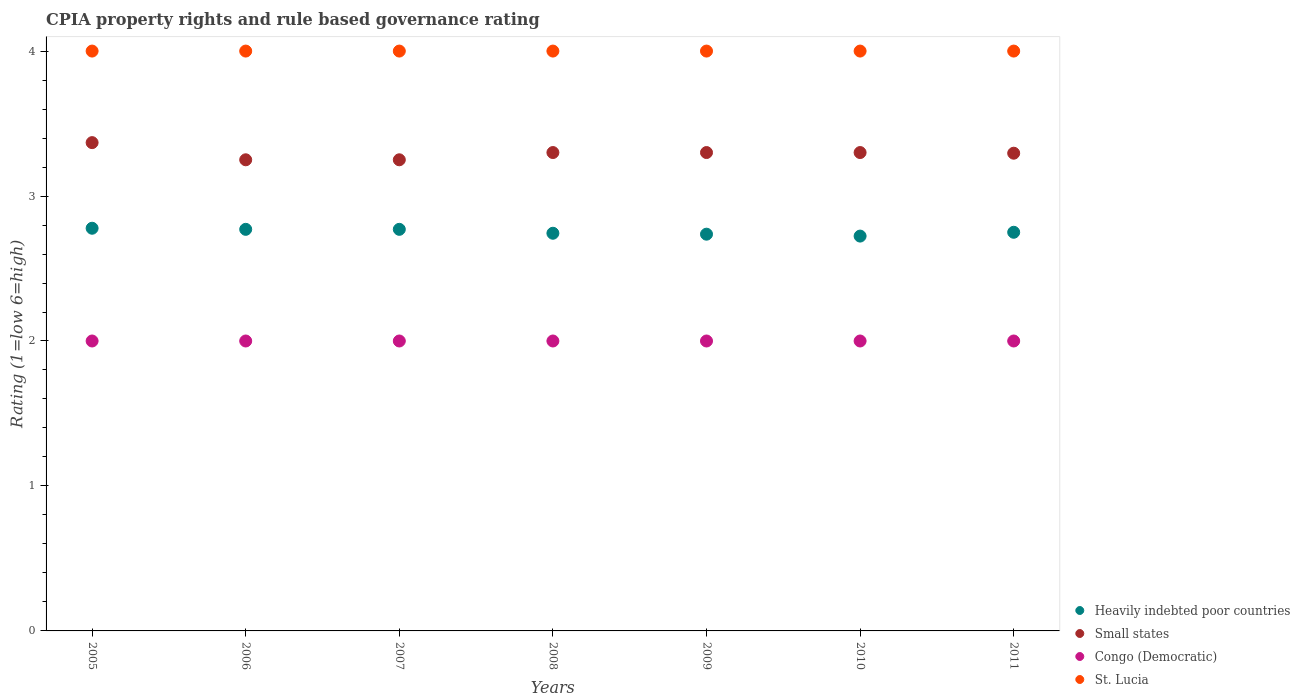How many different coloured dotlines are there?
Offer a terse response. 4. What is the CPIA rating in St. Lucia in 2009?
Your answer should be compact. 4. Across all years, what is the maximum CPIA rating in St. Lucia?
Offer a terse response. 4. Across all years, what is the minimum CPIA rating in Congo (Democratic)?
Make the answer very short. 2. In which year was the CPIA rating in Heavily indebted poor countries maximum?
Keep it short and to the point. 2005. In which year was the CPIA rating in Heavily indebted poor countries minimum?
Provide a short and direct response. 2010. What is the total CPIA rating in Small states in the graph?
Your answer should be compact. 23.06. What is the difference between the CPIA rating in Heavily indebted poor countries in 2008 and that in 2010?
Keep it short and to the point. 0.02. What is the difference between the CPIA rating in St. Lucia in 2011 and the CPIA rating in Congo (Democratic) in 2007?
Make the answer very short. 2. What is the average CPIA rating in Small states per year?
Your answer should be very brief. 3.29. In the year 2005, what is the difference between the CPIA rating in St. Lucia and CPIA rating in Small states?
Offer a very short reply. 0.63. In how many years, is the CPIA rating in St. Lucia greater than 0.6000000000000001?
Offer a terse response. 7. Is the difference between the CPIA rating in St. Lucia in 2005 and 2010 greater than the difference between the CPIA rating in Small states in 2005 and 2010?
Keep it short and to the point. No. What is the difference between the highest and the second highest CPIA rating in Heavily indebted poor countries?
Offer a terse response. 0.01. What is the difference between the highest and the lowest CPIA rating in Small states?
Make the answer very short. 0.12. In how many years, is the CPIA rating in Small states greater than the average CPIA rating in Small states taken over all years?
Your answer should be compact. 5. Is it the case that in every year, the sum of the CPIA rating in Heavily indebted poor countries and CPIA rating in Congo (Democratic)  is greater than the sum of CPIA rating in Small states and CPIA rating in St. Lucia?
Make the answer very short. No. Does the CPIA rating in St. Lucia monotonically increase over the years?
Make the answer very short. No. Is the CPIA rating in Congo (Democratic) strictly less than the CPIA rating in Small states over the years?
Provide a short and direct response. Yes. How many dotlines are there?
Your answer should be very brief. 4. Does the graph contain grids?
Make the answer very short. No. Where does the legend appear in the graph?
Your answer should be very brief. Bottom right. What is the title of the graph?
Provide a succinct answer. CPIA property rights and rule based governance rating. Does "Algeria" appear as one of the legend labels in the graph?
Make the answer very short. No. What is the Rating (1=low 6=high) in Heavily indebted poor countries in 2005?
Your response must be concise. 2.78. What is the Rating (1=low 6=high) in Small states in 2005?
Your answer should be very brief. 3.37. What is the Rating (1=low 6=high) in St. Lucia in 2005?
Your answer should be compact. 4. What is the Rating (1=low 6=high) of Heavily indebted poor countries in 2006?
Provide a short and direct response. 2.77. What is the Rating (1=low 6=high) of Small states in 2006?
Your answer should be very brief. 3.25. What is the Rating (1=low 6=high) in Congo (Democratic) in 2006?
Provide a succinct answer. 2. What is the Rating (1=low 6=high) in St. Lucia in 2006?
Your answer should be very brief. 4. What is the Rating (1=low 6=high) of Heavily indebted poor countries in 2007?
Your answer should be very brief. 2.77. What is the Rating (1=low 6=high) of Congo (Democratic) in 2007?
Offer a terse response. 2. What is the Rating (1=low 6=high) in St. Lucia in 2007?
Your answer should be compact. 4. What is the Rating (1=low 6=high) of Heavily indebted poor countries in 2008?
Ensure brevity in your answer.  2.74. What is the Rating (1=low 6=high) of Congo (Democratic) in 2008?
Offer a very short reply. 2. What is the Rating (1=low 6=high) of St. Lucia in 2008?
Your answer should be compact. 4. What is the Rating (1=low 6=high) of Heavily indebted poor countries in 2009?
Keep it short and to the point. 2.74. What is the Rating (1=low 6=high) of St. Lucia in 2009?
Give a very brief answer. 4. What is the Rating (1=low 6=high) in Heavily indebted poor countries in 2010?
Keep it short and to the point. 2.72. What is the Rating (1=low 6=high) in Congo (Democratic) in 2010?
Provide a short and direct response. 2. What is the Rating (1=low 6=high) in Heavily indebted poor countries in 2011?
Offer a terse response. 2.75. What is the Rating (1=low 6=high) in Small states in 2011?
Make the answer very short. 3.3. Across all years, what is the maximum Rating (1=low 6=high) in Heavily indebted poor countries?
Keep it short and to the point. 2.78. Across all years, what is the maximum Rating (1=low 6=high) of Small states?
Your answer should be very brief. 3.37. Across all years, what is the maximum Rating (1=low 6=high) in Congo (Democratic)?
Provide a succinct answer. 2. Across all years, what is the maximum Rating (1=low 6=high) in St. Lucia?
Ensure brevity in your answer.  4. Across all years, what is the minimum Rating (1=low 6=high) in Heavily indebted poor countries?
Provide a succinct answer. 2.72. Across all years, what is the minimum Rating (1=low 6=high) of Small states?
Provide a succinct answer. 3.25. Across all years, what is the minimum Rating (1=low 6=high) in St. Lucia?
Ensure brevity in your answer.  4. What is the total Rating (1=low 6=high) in Heavily indebted poor countries in the graph?
Keep it short and to the point. 19.27. What is the total Rating (1=low 6=high) of Small states in the graph?
Offer a very short reply. 23.06. What is the total Rating (1=low 6=high) of St. Lucia in the graph?
Offer a very short reply. 28. What is the difference between the Rating (1=low 6=high) in Heavily indebted poor countries in 2005 and that in 2006?
Ensure brevity in your answer.  0.01. What is the difference between the Rating (1=low 6=high) in Small states in 2005 and that in 2006?
Make the answer very short. 0.12. What is the difference between the Rating (1=low 6=high) in Congo (Democratic) in 2005 and that in 2006?
Give a very brief answer. 0. What is the difference between the Rating (1=low 6=high) in St. Lucia in 2005 and that in 2006?
Your answer should be compact. 0. What is the difference between the Rating (1=low 6=high) in Heavily indebted poor countries in 2005 and that in 2007?
Your answer should be compact. 0.01. What is the difference between the Rating (1=low 6=high) of Small states in 2005 and that in 2007?
Your answer should be very brief. 0.12. What is the difference between the Rating (1=low 6=high) of Heavily indebted poor countries in 2005 and that in 2008?
Ensure brevity in your answer.  0.03. What is the difference between the Rating (1=low 6=high) of Small states in 2005 and that in 2008?
Keep it short and to the point. 0.07. What is the difference between the Rating (1=low 6=high) of St. Lucia in 2005 and that in 2008?
Your answer should be very brief. 0. What is the difference between the Rating (1=low 6=high) in Heavily indebted poor countries in 2005 and that in 2009?
Provide a short and direct response. 0.04. What is the difference between the Rating (1=low 6=high) in Small states in 2005 and that in 2009?
Offer a very short reply. 0.07. What is the difference between the Rating (1=low 6=high) in St. Lucia in 2005 and that in 2009?
Offer a terse response. 0. What is the difference between the Rating (1=low 6=high) in Heavily indebted poor countries in 2005 and that in 2010?
Make the answer very short. 0.05. What is the difference between the Rating (1=low 6=high) of Small states in 2005 and that in 2010?
Offer a very short reply. 0.07. What is the difference between the Rating (1=low 6=high) in Heavily indebted poor countries in 2005 and that in 2011?
Provide a succinct answer. 0.03. What is the difference between the Rating (1=low 6=high) of Small states in 2005 and that in 2011?
Provide a succinct answer. 0.07. What is the difference between the Rating (1=low 6=high) of Heavily indebted poor countries in 2006 and that in 2007?
Provide a short and direct response. 0. What is the difference between the Rating (1=low 6=high) in Small states in 2006 and that in 2007?
Offer a terse response. 0. What is the difference between the Rating (1=low 6=high) of Congo (Democratic) in 2006 and that in 2007?
Your answer should be compact. 0. What is the difference between the Rating (1=low 6=high) in Heavily indebted poor countries in 2006 and that in 2008?
Give a very brief answer. 0.03. What is the difference between the Rating (1=low 6=high) in Small states in 2006 and that in 2008?
Your answer should be very brief. -0.05. What is the difference between the Rating (1=low 6=high) in Heavily indebted poor countries in 2006 and that in 2009?
Provide a short and direct response. 0.03. What is the difference between the Rating (1=low 6=high) of Small states in 2006 and that in 2009?
Give a very brief answer. -0.05. What is the difference between the Rating (1=low 6=high) in St. Lucia in 2006 and that in 2009?
Your response must be concise. 0. What is the difference between the Rating (1=low 6=high) in Heavily indebted poor countries in 2006 and that in 2010?
Ensure brevity in your answer.  0.05. What is the difference between the Rating (1=low 6=high) of Small states in 2006 and that in 2010?
Provide a short and direct response. -0.05. What is the difference between the Rating (1=low 6=high) of Congo (Democratic) in 2006 and that in 2010?
Provide a succinct answer. 0. What is the difference between the Rating (1=low 6=high) of Heavily indebted poor countries in 2006 and that in 2011?
Make the answer very short. 0.02. What is the difference between the Rating (1=low 6=high) of Small states in 2006 and that in 2011?
Keep it short and to the point. -0.05. What is the difference between the Rating (1=low 6=high) in Congo (Democratic) in 2006 and that in 2011?
Give a very brief answer. 0. What is the difference between the Rating (1=low 6=high) of St. Lucia in 2006 and that in 2011?
Your answer should be compact. 0. What is the difference between the Rating (1=low 6=high) of Heavily indebted poor countries in 2007 and that in 2008?
Offer a very short reply. 0.03. What is the difference between the Rating (1=low 6=high) of Congo (Democratic) in 2007 and that in 2008?
Your answer should be compact. 0. What is the difference between the Rating (1=low 6=high) of St. Lucia in 2007 and that in 2008?
Give a very brief answer. 0. What is the difference between the Rating (1=low 6=high) in Heavily indebted poor countries in 2007 and that in 2009?
Your response must be concise. 0.03. What is the difference between the Rating (1=low 6=high) of Congo (Democratic) in 2007 and that in 2009?
Your answer should be very brief. 0. What is the difference between the Rating (1=low 6=high) in Heavily indebted poor countries in 2007 and that in 2010?
Provide a short and direct response. 0.05. What is the difference between the Rating (1=low 6=high) in Heavily indebted poor countries in 2007 and that in 2011?
Your response must be concise. 0.02. What is the difference between the Rating (1=low 6=high) in Small states in 2007 and that in 2011?
Provide a succinct answer. -0.05. What is the difference between the Rating (1=low 6=high) in Congo (Democratic) in 2007 and that in 2011?
Give a very brief answer. 0. What is the difference between the Rating (1=low 6=high) of Heavily indebted poor countries in 2008 and that in 2009?
Provide a succinct answer. 0.01. What is the difference between the Rating (1=low 6=high) in Small states in 2008 and that in 2009?
Provide a succinct answer. 0. What is the difference between the Rating (1=low 6=high) of Congo (Democratic) in 2008 and that in 2009?
Your answer should be very brief. 0. What is the difference between the Rating (1=low 6=high) of St. Lucia in 2008 and that in 2009?
Your answer should be very brief. 0. What is the difference between the Rating (1=low 6=high) of Heavily indebted poor countries in 2008 and that in 2010?
Ensure brevity in your answer.  0.02. What is the difference between the Rating (1=low 6=high) in Small states in 2008 and that in 2010?
Offer a terse response. 0. What is the difference between the Rating (1=low 6=high) of Congo (Democratic) in 2008 and that in 2010?
Give a very brief answer. 0. What is the difference between the Rating (1=low 6=high) in St. Lucia in 2008 and that in 2010?
Your answer should be very brief. 0. What is the difference between the Rating (1=low 6=high) in Heavily indebted poor countries in 2008 and that in 2011?
Offer a very short reply. -0.01. What is the difference between the Rating (1=low 6=high) of Small states in 2008 and that in 2011?
Your answer should be compact. 0. What is the difference between the Rating (1=low 6=high) in Congo (Democratic) in 2008 and that in 2011?
Offer a terse response. 0. What is the difference between the Rating (1=low 6=high) of Heavily indebted poor countries in 2009 and that in 2010?
Offer a very short reply. 0.01. What is the difference between the Rating (1=low 6=high) of Small states in 2009 and that in 2010?
Give a very brief answer. 0. What is the difference between the Rating (1=low 6=high) of St. Lucia in 2009 and that in 2010?
Ensure brevity in your answer.  0. What is the difference between the Rating (1=low 6=high) of Heavily indebted poor countries in 2009 and that in 2011?
Give a very brief answer. -0.01. What is the difference between the Rating (1=low 6=high) of Small states in 2009 and that in 2011?
Your answer should be compact. 0. What is the difference between the Rating (1=low 6=high) of Congo (Democratic) in 2009 and that in 2011?
Offer a very short reply. 0. What is the difference between the Rating (1=low 6=high) in Heavily indebted poor countries in 2010 and that in 2011?
Provide a succinct answer. -0.03. What is the difference between the Rating (1=low 6=high) of Small states in 2010 and that in 2011?
Provide a short and direct response. 0. What is the difference between the Rating (1=low 6=high) of St. Lucia in 2010 and that in 2011?
Your answer should be very brief. 0. What is the difference between the Rating (1=low 6=high) of Heavily indebted poor countries in 2005 and the Rating (1=low 6=high) of Small states in 2006?
Your answer should be compact. -0.47. What is the difference between the Rating (1=low 6=high) of Heavily indebted poor countries in 2005 and the Rating (1=low 6=high) of St. Lucia in 2006?
Give a very brief answer. -1.22. What is the difference between the Rating (1=low 6=high) of Small states in 2005 and the Rating (1=low 6=high) of Congo (Democratic) in 2006?
Your response must be concise. 1.37. What is the difference between the Rating (1=low 6=high) of Small states in 2005 and the Rating (1=low 6=high) of St. Lucia in 2006?
Keep it short and to the point. -0.63. What is the difference between the Rating (1=low 6=high) in Congo (Democratic) in 2005 and the Rating (1=low 6=high) in St. Lucia in 2006?
Keep it short and to the point. -2. What is the difference between the Rating (1=low 6=high) of Heavily indebted poor countries in 2005 and the Rating (1=low 6=high) of Small states in 2007?
Ensure brevity in your answer.  -0.47. What is the difference between the Rating (1=low 6=high) of Heavily indebted poor countries in 2005 and the Rating (1=low 6=high) of St. Lucia in 2007?
Your answer should be compact. -1.22. What is the difference between the Rating (1=low 6=high) in Small states in 2005 and the Rating (1=low 6=high) in Congo (Democratic) in 2007?
Your answer should be very brief. 1.37. What is the difference between the Rating (1=low 6=high) of Small states in 2005 and the Rating (1=low 6=high) of St. Lucia in 2007?
Make the answer very short. -0.63. What is the difference between the Rating (1=low 6=high) in Congo (Democratic) in 2005 and the Rating (1=low 6=high) in St. Lucia in 2007?
Provide a succinct answer. -2. What is the difference between the Rating (1=low 6=high) in Heavily indebted poor countries in 2005 and the Rating (1=low 6=high) in Small states in 2008?
Ensure brevity in your answer.  -0.52. What is the difference between the Rating (1=low 6=high) of Heavily indebted poor countries in 2005 and the Rating (1=low 6=high) of St. Lucia in 2008?
Make the answer very short. -1.22. What is the difference between the Rating (1=low 6=high) of Small states in 2005 and the Rating (1=low 6=high) of Congo (Democratic) in 2008?
Offer a very short reply. 1.37. What is the difference between the Rating (1=low 6=high) of Small states in 2005 and the Rating (1=low 6=high) of St. Lucia in 2008?
Provide a short and direct response. -0.63. What is the difference between the Rating (1=low 6=high) in Heavily indebted poor countries in 2005 and the Rating (1=low 6=high) in Small states in 2009?
Make the answer very short. -0.52. What is the difference between the Rating (1=low 6=high) in Heavily indebted poor countries in 2005 and the Rating (1=low 6=high) in Congo (Democratic) in 2009?
Your answer should be very brief. 0.78. What is the difference between the Rating (1=low 6=high) in Heavily indebted poor countries in 2005 and the Rating (1=low 6=high) in St. Lucia in 2009?
Offer a very short reply. -1.22. What is the difference between the Rating (1=low 6=high) of Small states in 2005 and the Rating (1=low 6=high) of Congo (Democratic) in 2009?
Provide a succinct answer. 1.37. What is the difference between the Rating (1=low 6=high) of Small states in 2005 and the Rating (1=low 6=high) of St. Lucia in 2009?
Your answer should be very brief. -0.63. What is the difference between the Rating (1=low 6=high) of Heavily indebted poor countries in 2005 and the Rating (1=low 6=high) of Small states in 2010?
Offer a terse response. -0.52. What is the difference between the Rating (1=low 6=high) of Heavily indebted poor countries in 2005 and the Rating (1=low 6=high) of Congo (Democratic) in 2010?
Your answer should be compact. 0.78. What is the difference between the Rating (1=low 6=high) in Heavily indebted poor countries in 2005 and the Rating (1=low 6=high) in St. Lucia in 2010?
Keep it short and to the point. -1.22. What is the difference between the Rating (1=low 6=high) of Small states in 2005 and the Rating (1=low 6=high) of Congo (Democratic) in 2010?
Offer a very short reply. 1.37. What is the difference between the Rating (1=low 6=high) in Small states in 2005 and the Rating (1=low 6=high) in St. Lucia in 2010?
Your response must be concise. -0.63. What is the difference between the Rating (1=low 6=high) in Heavily indebted poor countries in 2005 and the Rating (1=low 6=high) in Small states in 2011?
Offer a very short reply. -0.52. What is the difference between the Rating (1=low 6=high) in Heavily indebted poor countries in 2005 and the Rating (1=low 6=high) in St. Lucia in 2011?
Provide a succinct answer. -1.22. What is the difference between the Rating (1=low 6=high) in Small states in 2005 and the Rating (1=low 6=high) in Congo (Democratic) in 2011?
Provide a short and direct response. 1.37. What is the difference between the Rating (1=low 6=high) of Small states in 2005 and the Rating (1=low 6=high) of St. Lucia in 2011?
Offer a very short reply. -0.63. What is the difference between the Rating (1=low 6=high) in Heavily indebted poor countries in 2006 and the Rating (1=low 6=high) in Small states in 2007?
Offer a terse response. -0.48. What is the difference between the Rating (1=low 6=high) in Heavily indebted poor countries in 2006 and the Rating (1=low 6=high) in Congo (Democratic) in 2007?
Offer a very short reply. 0.77. What is the difference between the Rating (1=low 6=high) of Heavily indebted poor countries in 2006 and the Rating (1=low 6=high) of St. Lucia in 2007?
Your response must be concise. -1.23. What is the difference between the Rating (1=low 6=high) of Small states in 2006 and the Rating (1=low 6=high) of Congo (Democratic) in 2007?
Offer a very short reply. 1.25. What is the difference between the Rating (1=low 6=high) in Small states in 2006 and the Rating (1=low 6=high) in St. Lucia in 2007?
Your response must be concise. -0.75. What is the difference between the Rating (1=low 6=high) of Heavily indebted poor countries in 2006 and the Rating (1=low 6=high) of Small states in 2008?
Provide a short and direct response. -0.53. What is the difference between the Rating (1=low 6=high) in Heavily indebted poor countries in 2006 and the Rating (1=low 6=high) in Congo (Democratic) in 2008?
Offer a very short reply. 0.77. What is the difference between the Rating (1=low 6=high) in Heavily indebted poor countries in 2006 and the Rating (1=low 6=high) in St. Lucia in 2008?
Offer a very short reply. -1.23. What is the difference between the Rating (1=low 6=high) in Small states in 2006 and the Rating (1=low 6=high) in Congo (Democratic) in 2008?
Provide a succinct answer. 1.25. What is the difference between the Rating (1=low 6=high) in Small states in 2006 and the Rating (1=low 6=high) in St. Lucia in 2008?
Keep it short and to the point. -0.75. What is the difference between the Rating (1=low 6=high) in Congo (Democratic) in 2006 and the Rating (1=low 6=high) in St. Lucia in 2008?
Your answer should be compact. -2. What is the difference between the Rating (1=low 6=high) of Heavily indebted poor countries in 2006 and the Rating (1=low 6=high) of Small states in 2009?
Offer a terse response. -0.53. What is the difference between the Rating (1=low 6=high) in Heavily indebted poor countries in 2006 and the Rating (1=low 6=high) in Congo (Democratic) in 2009?
Give a very brief answer. 0.77. What is the difference between the Rating (1=low 6=high) in Heavily indebted poor countries in 2006 and the Rating (1=low 6=high) in St. Lucia in 2009?
Offer a very short reply. -1.23. What is the difference between the Rating (1=low 6=high) in Small states in 2006 and the Rating (1=low 6=high) in St. Lucia in 2009?
Keep it short and to the point. -0.75. What is the difference between the Rating (1=low 6=high) in Congo (Democratic) in 2006 and the Rating (1=low 6=high) in St. Lucia in 2009?
Provide a short and direct response. -2. What is the difference between the Rating (1=low 6=high) in Heavily indebted poor countries in 2006 and the Rating (1=low 6=high) in Small states in 2010?
Make the answer very short. -0.53. What is the difference between the Rating (1=low 6=high) of Heavily indebted poor countries in 2006 and the Rating (1=low 6=high) of Congo (Democratic) in 2010?
Ensure brevity in your answer.  0.77. What is the difference between the Rating (1=low 6=high) of Heavily indebted poor countries in 2006 and the Rating (1=low 6=high) of St. Lucia in 2010?
Offer a very short reply. -1.23. What is the difference between the Rating (1=low 6=high) of Small states in 2006 and the Rating (1=low 6=high) of Congo (Democratic) in 2010?
Your answer should be compact. 1.25. What is the difference between the Rating (1=low 6=high) of Small states in 2006 and the Rating (1=low 6=high) of St. Lucia in 2010?
Keep it short and to the point. -0.75. What is the difference between the Rating (1=low 6=high) in Congo (Democratic) in 2006 and the Rating (1=low 6=high) in St. Lucia in 2010?
Make the answer very short. -2. What is the difference between the Rating (1=low 6=high) of Heavily indebted poor countries in 2006 and the Rating (1=low 6=high) of Small states in 2011?
Offer a terse response. -0.53. What is the difference between the Rating (1=low 6=high) of Heavily indebted poor countries in 2006 and the Rating (1=low 6=high) of Congo (Democratic) in 2011?
Your response must be concise. 0.77. What is the difference between the Rating (1=low 6=high) in Heavily indebted poor countries in 2006 and the Rating (1=low 6=high) in St. Lucia in 2011?
Provide a succinct answer. -1.23. What is the difference between the Rating (1=low 6=high) in Small states in 2006 and the Rating (1=low 6=high) in Congo (Democratic) in 2011?
Your answer should be very brief. 1.25. What is the difference between the Rating (1=low 6=high) of Small states in 2006 and the Rating (1=low 6=high) of St. Lucia in 2011?
Your answer should be compact. -0.75. What is the difference between the Rating (1=low 6=high) in Congo (Democratic) in 2006 and the Rating (1=low 6=high) in St. Lucia in 2011?
Provide a short and direct response. -2. What is the difference between the Rating (1=low 6=high) in Heavily indebted poor countries in 2007 and the Rating (1=low 6=high) in Small states in 2008?
Your answer should be very brief. -0.53. What is the difference between the Rating (1=low 6=high) of Heavily indebted poor countries in 2007 and the Rating (1=low 6=high) of Congo (Democratic) in 2008?
Make the answer very short. 0.77. What is the difference between the Rating (1=low 6=high) in Heavily indebted poor countries in 2007 and the Rating (1=low 6=high) in St. Lucia in 2008?
Ensure brevity in your answer.  -1.23. What is the difference between the Rating (1=low 6=high) of Small states in 2007 and the Rating (1=low 6=high) of St. Lucia in 2008?
Give a very brief answer. -0.75. What is the difference between the Rating (1=low 6=high) in Congo (Democratic) in 2007 and the Rating (1=low 6=high) in St. Lucia in 2008?
Your answer should be compact. -2. What is the difference between the Rating (1=low 6=high) of Heavily indebted poor countries in 2007 and the Rating (1=low 6=high) of Small states in 2009?
Make the answer very short. -0.53. What is the difference between the Rating (1=low 6=high) of Heavily indebted poor countries in 2007 and the Rating (1=low 6=high) of Congo (Democratic) in 2009?
Provide a short and direct response. 0.77. What is the difference between the Rating (1=low 6=high) of Heavily indebted poor countries in 2007 and the Rating (1=low 6=high) of St. Lucia in 2009?
Make the answer very short. -1.23. What is the difference between the Rating (1=low 6=high) in Small states in 2007 and the Rating (1=low 6=high) in Congo (Democratic) in 2009?
Make the answer very short. 1.25. What is the difference between the Rating (1=low 6=high) of Small states in 2007 and the Rating (1=low 6=high) of St. Lucia in 2009?
Offer a very short reply. -0.75. What is the difference between the Rating (1=low 6=high) of Heavily indebted poor countries in 2007 and the Rating (1=low 6=high) of Small states in 2010?
Keep it short and to the point. -0.53. What is the difference between the Rating (1=low 6=high) of Heavily indebted poor countries in 2007 and the Rating (1=low 6=high) of Congo (Democratic) in 2010?
Ensure brevity in your answer.  0.77. What is the difference between the Rating (1=low 6=high) of Heavily indebted poor countries in 2007 and the Rating (1=low 6=high) of St. Lucia in 2010?
Ensure brevity in your answer.  -1.23. What is the difference between the Rating (1=low 6=high) of Small states in 2007 and the Rating (1=low 6=high) of St. Lucia in 2010?
Ensure brevity in your answer.  -0.75. What is the difference between the Rating (1=low 6=high) of Congo (Democratic) in 2007 and the Rating (1=low 6=high) of St. Lucia in 2010?
Provide a succinct answer. -2. What is the difference between the Rating (1=low 6=high) of Heavily indebted poor countries in 2007 and the Rating (1=low 6=high) of Small states in 2011?
Your answer should be compact. -0.53. What is the difference between the Rating (1=low 6=high) of Heavily indebted poor countries in 2007 and the Rating (1=low 6=high) of Congo (Democratic) in 2011?
Your answer should be very brief. 0.77. What is the difference between the Rating (1=low 6=high) of Heavily indebted poor countries in 2007 and the Rating (1=low 6=high) of St. Lucia in 2011?
Offer a very short reply. -1.23. What is the difference between the Rating (1=low 6=high) of Small states in 2007 and the Rating (1=low 6=high) of Congo (Democratic) in 2011?
Give a very brief answer. 1.25. What is the difference between the Rating (1=low 6=high) of Small states in 2007 and the Rating (1=low 6=high) of St. Lucia in 2011?
Offer a very short reply. -0.75. What is the difference between the Rating (1=low 6=high) of Heavily indebted poor countries in 2008 and the Rating (1=low 6=high) of Small states in 2009?
Your response must be concise. -0.56. What is the difference between the Rating (1=low 6=high) of Heavily indebted poor countries in 2008 and the Rating (1=low 6=high) of Congo (Democratic) in 2009?
Keep it short and to the point. 0.74. What is the difference between the Rating (1=low 6=high) of Heavily indebted poor countries in 2008 and the Rating (1=low 6=high) of St. Lucia in 2009?
Ensure brevity in your answer.  -1.26. What is the difference between the Rating (1=low 6=high) of Small states in 2008 and the Rating (1=low 6=high) of Congo (Democratic) in 2009?
Keep it short and to the point. 1.3. What is the difference between the Rating (1=low 6=high) of Heavily indebted poor countries in 2008 and the Rating (1=low 6=high) of Small states in 2010?
Your answer should be very brief. -0.56. What is the difference between the Rating (1=low 6=high) of Heavily indebted poor countries in 2008 and the Rating (1=low 6=high) of Congo (Democratic) in 2010?
Your response must be concise. 0.74. What is the difference between the Rating (1=low 6=high) of Heavily indebted poor countries in 2008 and the Rating (1=low 6=high) of St. Lucia in 2010?
Keep it short and to the point. -1.26. What is the difference between the Rating (1=low 6=high) of Small states in 2008 and the Rating (1=low 6=high) of St. Lucia in 2010?
Offer a very short reply. -0.7. What is the difference between the Rating (1=low 6=high) of Heavily indebted poor countries in 2008 and the Rating (1=low 6=high) of Small states in 2011?
Ensure brevity in your answer.  -0.55. What is the difference between the Rating (1=low 6=high) in Heavily indebted poor countries in 2008 and the Rating (1=low 6=high) in Congo (Democratic) in 2011?
Make the answer very short. 0.74. What is the difference between the Rating (1=low 6=high) of Heavily indebted poor countries in 2008 and the Rating (1=low 6=high) of St. Lucia in 2011?
Keep it short and to the point. -1.26. What is the difference between the Rating (1=low 6=high) in Small states in 2008 and the Rating (1=low 6=high) in Congo (Democratic) in 2011?
Your answer should be very brief. 1.3. What is the difference between the Rating (1=low 6=high) in Congo (Democratic) in 2008 and the Rating (1=low 6=high) in St. Lucia in 2011?
Ensure brevity in your answer.  -2. What is the difference between the Rating (1=low 6=high) in Heavily indebted poor countries in 2009 and the Rating (1=low 6=high) in Small states in 2010?
Your answer should be compact. -0.56. What is the difference between the Rating (1=low 6=high) in Heavily indebted poor countries in 2009 and the Rating (1=low 6=high) in Congo (Democratic) in 2010?
Give a very brief answer. 0.74. What is the difference between the Rating (1=low 6=high) in Heavily indebted poor countries in 2009 and the Rating (1=low 6=high) in St. Lucia in 2010?
Ensure brevity in your answer.  -1.26. What is the difference between the Rating (1=low 6=high) in Small states in 2009 and the Rating (1=low 6=high) in Congo (Democratic) in 2010?
Give a very brief answer. 1.3. What is the difference between the Rating (1=low 6=high) in Heavily indebted poor countries in 2009 and the Rating (1=low 6=high) in Small states in 2011?
Your answer should be compact. -0.56. What is the difference between the Rating (1=low 6=high) in Heavily indebted poor countries in 2009 and the Rating (1=low 6=high) in Congo (Democratic) in 2011?
Keep it short and to the point. 0.74. What is the difference between the Rating (1=low 6=high) of Heavily indebted poor countries in 2009 and the Rating (1=low 6=high) of St. Lucia in 2011?
Keep it short and to the point. -1.26. What is the difference between the Rating (1=low 6=high) in Small states in 2009 and the Rating (1=low 6=high) in Congo (Democratic) in 2011?
Your answer should be compact. 1.3. What is the difference between the Rating (1=low 6=high) in Heavily indebted poor countries in 2010 and the Rating (1=low 6=high) in Small states in 2011?
Your answer should be very brief. -0.57. What is the difference between the Rating (1=low 6=high) in Heavily indebted poor countries in 2010 and the Rating (1=low 6=high) in Congo (Democratic) in 2011?
Offer a terse response. 0.72. What is the difference between the Rating (1=low 6=high) in Heavily indebted poor countries in 2010 and the Rating (1=low 6=high) in St. Lucia in 2011?
Provide a short and direct response. -1.28. What is the difference between the Rating (1=low 6=high) in Small states in 2010 and the Rating (1=low 6=high) in St. Lucia in 2011?
Offer a very short reply. -0.7. What is the difference between the Rating (1=low 6=high) of Congo (Democratic) in 2010 and the Rating (1=low 6=high) of St. Lucia in 2011?
Give a very brief answer. -2. What is the average Rating (1=low 6=high) in Heavily indebted poor countries per year?
Keep it short and to the point. 2.75. What is the average Rating (1=low 6=high) in Small states per year?
Give a very brief answer. 3.29. What is the average Rating (1=low 6=high) of Congo (Democratic) per year?
Provide a succinct answer. 2. In the year 2005, what is the difference between the Rating (1=low 6=high) of Heavily indebted poor countries and Rating (1=low 6=high) of Small states?
Your response must be concise. -0.59. In the year 2005, what is the difference between the Rating (1=low 6=high) in Heavily indebted poor countries and Rating (1=low 6=high) in Congo (Democratic)?
Offer a very short reply. 0.78. In the year 2005, what is the difference between the Rating (1=low 6=high) of Heavily indebted poor countries and Rating (1=low 6=high) of St. Lucia?
Ensure brevity in your answer.  -1.22. In the year 2005, what is the difference between the Rating (1=low 6=high) in Small states and Rating (1=low 6=high) in Congo (Democratic)?
Provide a succinct answer. 1.37. In the year 2005, what is the difference between the Rating (1=low 6=high) of Small states and Rating (1=low 6=high) of St. Lucia?
Your answer should be compact. -0.63. In the year 2005, what is the difference between the Rating (1=low 6=high) in Congo (Democratic) and Rating (1=low 6=high) in St. Lucia?
Your answer should be very brief. -2. In the year 2006, what is the difference between the Rating (1=low 6=high) in Heavily indebted poor countries and Rating (1=low 6=high) in Small states?
Your answer should be very brief. -0.48. In the year 2006, what is the difference between the Rating (1=low 6=high) in Heavily indebted poor countries and Rating (1=low 6=high) in Congo (Democratic)?
Your response must be concise. 0.77. In the year 2006, what is the difference between the Rating (1=low 6=high) of Heavily indebted poor countries and Rating (1=low 6=high) of St. Lucia?
Offer a terse response. -1.23. In the year 2006, what is the difference between the Rating (1=low 6=high) of Small states and Rating (1=low 6=high) of St. Lucia?
Offer a very short reply. -0.75. In the year 2006, what is the difference between the Rating (1=low 6=high) of Congo (Democratic) and Rating (1=low 6=high) of St. Lucia?
Provide a succinct answer. -2. In the year 2007, what is the difference between the Rating (1=low 6=high) in Heavily indebted poor countries and Rating (1=low 6=high) in Small states?
Give a very brief answer. -0.48. In the year 2007, what is the difference between the Rating (1=low 6=high) in Heavily indebted poor countries and Rating (1=low 6=high) in Congo (Democratic)?
Your answer should be compact. 0.77. In the year 2007, what is the difference between the Rating (1=low 6=high) of Heavily indebted poor countries and Rating (1=low 6=high) of St. Lucia?
Provide a short and direct response. -1.23. In the year 2007, what is the difference between the Rating (1=low 6=high) of Small states and Rating (1=low 6=high) of Congo (Democratic)?
Your answer should be very brief. 1.25. In the year 2007, what is the difference between the Rating (1=low 6=high) of Small states and Rating (1=low 6=high) of St. Lucia?
Offer a terse response. -0.75. In the year 2007, what is the difference between the Rating (1=low 6=high) in Congo (Democratic) and Rating (1=low 6=high) in St. Lucia?
Keep it short and to the point. -2. In the year 2008, what is the difference between the Rating (1=low 6=high) in Heavily indebted poor countries and Rating (1=low 6=high) in Small states?
Keep it short and to the point. -0.56. In the year 2008, what is the difference between the Rating (1=low 6=high) in Heavily indebted poor countries and Rating (1=low 6=high) in Congo (Democratic)?
Offer a terse response. 0.74. In the year 2008, what is the difference between the Rating (1=low 6=high) of Heavily indebted poor countries and Rating (1=low 6=high) of St. Lucia?
Keep it short and to the point. -1.26. In the year 2009, what is the difference between the Rating (1=low 6=high) in Heavily indebted poor countries and Rating (1=low 6=high) in Small states?
Your answer should be compact. -0.56. In the year 2009, what is the difference between the Rating (1=low 6=high) in Heavily indebted poor countries and Rating (1=low 6=high) in Congo (Democratic)?
Ensure brevity in your answer.  0.74. In the year 2009, what is the difference between the Rating (1=low 6=high) of Heavily indebted poor countries and Rating (1=low 6=high) of St. Lucia?
Your answer should be compact. -1.26. In the year 2009, what is the difference between the Rating (1=low 6=high) of Small states and Rating (1=low 6=high) of Congo (Democratic)?
Your response must be concise. 1.3. In the year 2010, what is the difference between the Rating (1=low 6=high) in Heavily indebted poor countries and Rating (1=low 6=high) in Small states?
Provide a short and direct response. -0.58. In the year 2010, what is the difference between the Rating (1=low 6=high) of Heavily indebted poor countries and Rating (1=low 6=high) of Congo (Democratic)?
Keep it short and to the point. 0.72. In the year 2010, what is the difference between the Rating (1=low 6=high) of Heavily indebted poor countries and Rating (1=low 6=high) of St. Lucia?
Offer a very short reply. -1.28. In the year 2010, what is the difference between the Rating (1=low 6=high) of Small states and Rating (1=low 6=high) of Congo (Democratic)?
Your answer should be very brief. 1.3. In the year 2010, what is the difference between the Rating (1=low 6=high) of Small states and Rating (1=low 6=high) of St. Lucia?
Provide a short and direct response. -0.7. In the year 2010, what is the difference between the Rating (1=low 6=high) of Congo (Democratic) and Rating (1=low 6=high) of St. Lucia?
Make the answer very short. -2. In the year 2011, what is the difference between the Rating (1=low 6=high) in Heavily indebted poor countries and Rating (1=low 6=high) in Small states?
Give a very brief answer. -0.55. In the year 2011, what is the difference between the Rating (1=low 6=high) in Heavily indebted poor countries and Rating (1=low 6=high) in Congo (Democratic)?
Give a very brief answer. 0.75. In the year 2011, what is the difference between the Rating (1=low 6=high) of Heavily indebted poor countries and Rating (1=low 6=high) of St. Lucia?
Make the answer very short. -1.25. In the year 2011, what is the difference between the Rating (1=low 6=high) in Small states and Rating (1=low 6=high) in Congo (Democratic)?
Offer a terse response. 1.3. In the year 2011, what is the difference between the Rating (1=low 6=high) of Small states and Rating (1=low 6=high) of St. Lucia?
Provide a succinct answer. -0.7. In the year 2011, what is the difference between the Rating (1=low 6=high) of Congo (Democratic) and Rating (1=low 6=high) of St. Lucia?
Offer a terse response. -2. What is the ratio of the Rating (1=low 6=high) in Small states in 2005 to that in 2006?
Offer a terse response. 1.04. What is the ratio of the Rating (1=low 6=high) in Small states in 2005 to that in 2007?
Your answer should be very brief. 1.04. What is the ratio of the Rating (1=low 6=high) of Congo (Democratic) in 2005 to that in 2007?
Provide a short and direct response. 1. What is the ratio of the Rating (1=low 6=high) in St. Lucia in 2005 to that in 2007?
Your response must be concise. 1. What is the ratio of the Rating (1=low 6=high) in Heavily indebted poor countries in 2005 to that in 2008?
Provide a succinct answer. 1.01. What is the ratio of the Rating (1=low 6=high) in Small states in 2005 to that in 2008?
Your response must be concise. 1.02. What is the ratio of the Rating (1=low 6=high) in St. Lucia in 2005 to that in 2008?
Ensure brevity in your answer.  1. What is the ratio of the Rating (1=low 6=high) in Small states in 2005 to that in 2009?
Your response must be concise. 1.02. What is the ratio of the Rating (1=low 6=high) in St. Lucia in 2005 to that in 2009?
Make the answer very short. 1. What is the ratio of the Rating (1=low 6=high) in Heavily indebted poor countries in 2005 to that in 2010?
Give a very brief answer. 1.02. What is the ratio of the Rating (1=low 6=high) of Small states in 2005 to that in 2010?
Keep it short and to the point. 1.02. What is the ratio of the Rating (1=low 6=high) in St. Lucia in 2005 to that in 2010?
Keep it short and to the point. 1. What is the ratio of the Rating (1=low 6=high) of Small states in 2005 to that in 2011?
Provide a short and direct response. 1.02. What is the ratio of the Rating (1=low 6=high) in Congo (Democratic) in 2005 to that in 2011?
Your answer should be compact. 1. What is the ratio of the Rating (1=low 6=high) of St. Lucia in 2005 to that in 2011?
Ensure brevity in your answer.  1. What is the ratio of the Rating (1=low 6=high) of Heavily indebted poor countries in 2006 to that in 2007?
Provide a succinct answer. 1. What is the ratio of the Rating (1=low 6=high) of St. Lucia in 2006 to that in 2007?
Give a very brief answer. 1. What is the ratio of the Rating (1=low 6=high) of Heavily indebted poor countries in 2006 to that in 2008?
Your response must be concise. 1.01. What is the ratio of the Rating (1=low 6=high) of Small states in 2006 to that in 2008?
Your answer should be compact. 0.98. What is the ratio of the Rating (1=low 6=high) in Congo (Democratic) in 2006 to that in 2008?
Give a very brief answer. 1. What is the ratio of the Rating (1=low 6=high) of Heavily indebted poor countries in 2006 to that in 2009?
Ensure brevity in your answer.  1.01. What is the ratio of the Rating (1=low 6=high) in Congo (Democratic) in 2006 to that in 2009?
Make the answer very short. 1. What is the ratio of the Rating (1=low 6=high) in Heavily indebted poor countries in 2006 to that in 2010?
Give a very brief answer. 1.02. What is the ratio of the Rating (1=low 6=high) in Congo (Democratic) in 2006 to that in 2010?
Your answer should be very brief. 1. What is the ratio of the Rating (1=low 6=high) in Heavily indebted poor countries in 2006 to that in 2011?
Offer a very short reply. 1.01. What is the ratio of the Rating (1=low 6=high) of Small states in 2006 to that in 2011?
Make the answer very short. 0.99. What is the ratio of the Rating (1=low 6=high) of Congo (Democratic) in 2006 to that in 2011?
Offer a very short reply. 1. What is the ratio of the Rating (1=low 6=high) of Heavily indebted poor countries in 2007 to that in 2008?
Keep it short and to the point. 1.01. What is the ratio of the Rating (1=low 6=high) of Congo (Democratic) in 2007 to that in 2008?
Provide a succinct answer. 1. What is the ratio of the Rating (1=low 6=high) of Heavily indebted poor countries in 2007 to that in 2009?
Your answer should be very brief. 1.01. What is the ratio of the Rating (1=low 6=high) in Congo (Democratic) in 2007 to that in 2009?
Your response must be concise. 1. What is the ratio of the Rating (1=low 6=high) of St. Lucia in 2007 to that in 2009?
Ensure brevity in your answer.  1. What is the ratio of the Rating (1=low 6=high) in Heavily indebted poor countries in 2007 to that in 2010?
Provide a succinct answer. 1.02. What is the ratio of the Rating (1=low 6=high) in St. Lucia in 2007 to that in 2010?
Offer a terse response. 1. What is the ratio of the Rating (1=low 6=high) in Heavily indebted poor countries in 2007 to that in 2011?
Keep it short and to the point. 1.01. What is the ratio of the Rating (1=low 6=high) of Small states in 2007 to that in 2011?
Your answer should be very brief. 0.99. What is the ratio of the Rating (1=low 6=high) of St. Lucia in 2007 to that in 2011?
Keep it short and to the point. 1. What is the ratio of the Rating (1=low 6=high) in St. Lucia in 2008 to that in 2009?
Your answer should be compact. 1. What is the ratio of the Rating (1=low 6=high) in Small states in 2008 to that in 2010?
Give a very brief answer. 1. What is the ratio of the Rating (1=low 6=high) in Congo (Democratic) in 2008 to that in 2010?
Provide a short and direct response. 1. What is the ratio of the Rating (1=low 6=high) of St. Lucia in 2008 to that in 2010?
Your answer should be very brief. 1. What is the ratio of the Rating (1=low 6=high) of Congo (Democratic) in 2008 to that in 2011?
Your answer should be very brief. 1. What is the ratio of the Rating (1=low 6=high) of St. Lucia in 2008 to that in 2011?
Your answer should be compact. 1. What is the ratio of the Rating (1=low 6=high) in Heavily indebted poor countries in 2009 to that in 2010?
Your answer should be very brief. 1. What is the ratio of the Rating (1=low 6=high) of St. Lucia in 2009 to that in 2010?
Give a very brief answer. 1. What is the ratio of the Rating (1=low 6=high) in Heavily indebted poor countries in 2010 to that in 2011?
Ensure brevity in your answer.  0.99. What is the ratio of the Rating (1=low 6=high) of Small states in 2010 to that in 2011?
Your answer should be compact. 1. What is the difference between the highest and the second highest Rating (1=low 6=high) in Heavily indebted poor countries?
Offer a terse response. 0.01. What is the difference between the highest and the second highest Rating (1=low 6=high) in Small states?
Your response must be concise. 0.07. What is the difference between the highest and the second highest Rating (1=low 6=high) of Congo (Democratic)?
Provide a succinct answer. 0. What is the difference between the highest and the lowest Rating (1=low 6=high) of Heavily indebted poor countries?
Offer a terse response. 0.05. What is the difference between the highest and the lowest Rating (1=low 6=high) of Small states?
Ensure brevity in your answer.  0.12. What is the difference between the highest and the lowest Rating (1=low 6=high) in Congo (Democratic)?
Keep it short and to the point. 0. 